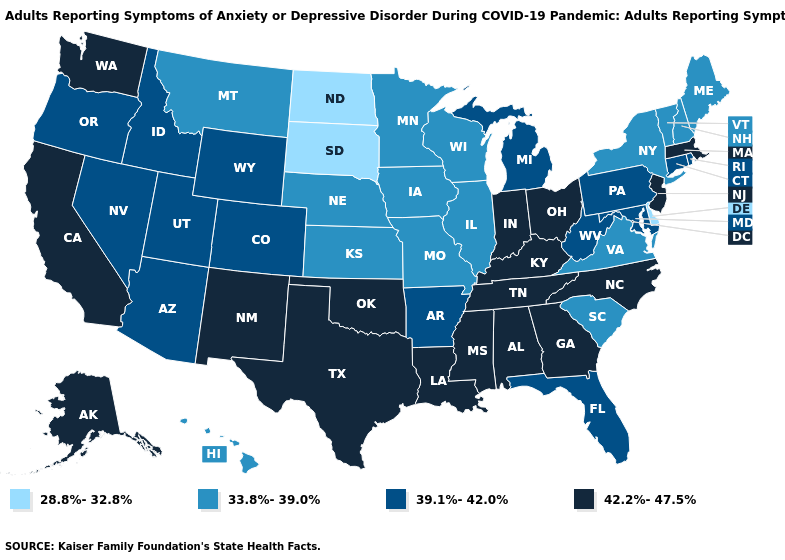What is the value of New Jersey?
Short answer required. 42.2%-47.5%. Name the states that have a value in the range 33.8%-39.0%?
Answer briefly. Hawaii, Illinois, Iowa, Kansas, Maine, Minnesota, Missouri, Montana, Nebraska, New Hampshire, New York, South Carolina, Vermont, Virginia, Wisconsin. What is the lowest value in the USA?
Answer briefly. 28.8%-32.8%. Which states have the highest value in the USA?
Keep it brief. Alabama, Alaska, California, Georgia, Indiana, Kentucky, Louisiana, Massachusetts, Mississippi, New Jersey, New Mexico, North Carolina, Ohio, Oklahoma, Tennessee, Texas, Washington. What is the value of Arizona?
Be succinct. 39.1%-42.0%. Among the states that border Indiana , which have the highest value?
Quick response, please. Kentucky, Ohio. How many symbols are there in the legend?
Keep it brief. 4. What is the value of Ohio?
Give a very brief answer. 42.2%-47.5%. What is the highest value in states that border Arizona?
Give a very brief answer. 42.2%-47.5%. What is the value of South Carolina?
Be succinct. 33.8%-39.0%. Does Wyoming have the lowest value in the West?
Quick response, please. No. What is the value of North Carolina?
Keep it brief. 42.2%-47.5%. What is the highest value in the Northeast ?
Write a very short answer. 42.2%-47.5%. Which states have the lowest value in the USA?
Write a very short answer. Delaware, North Dakota, South Dakota. How many symbols are there in the legend?
Keep it brief. 4. 